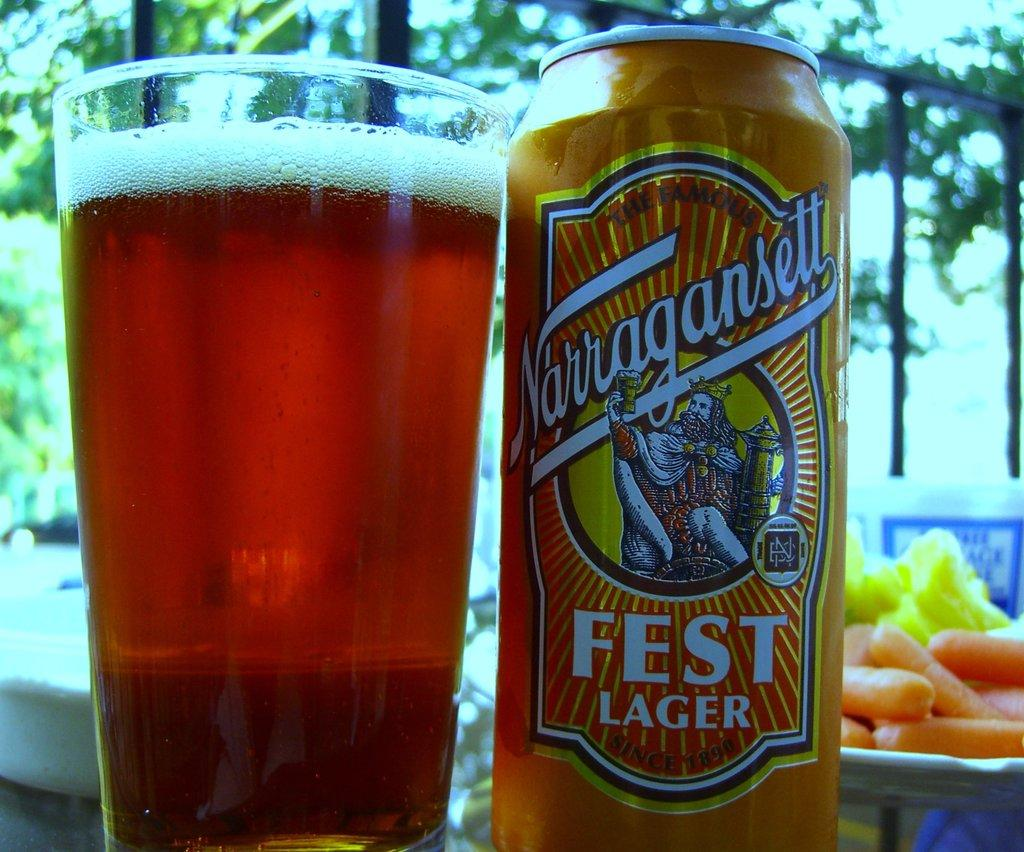<image>
Relay a brief, clear account of the picture shown. a can of narragansett fest lager standing next to a glass of it 